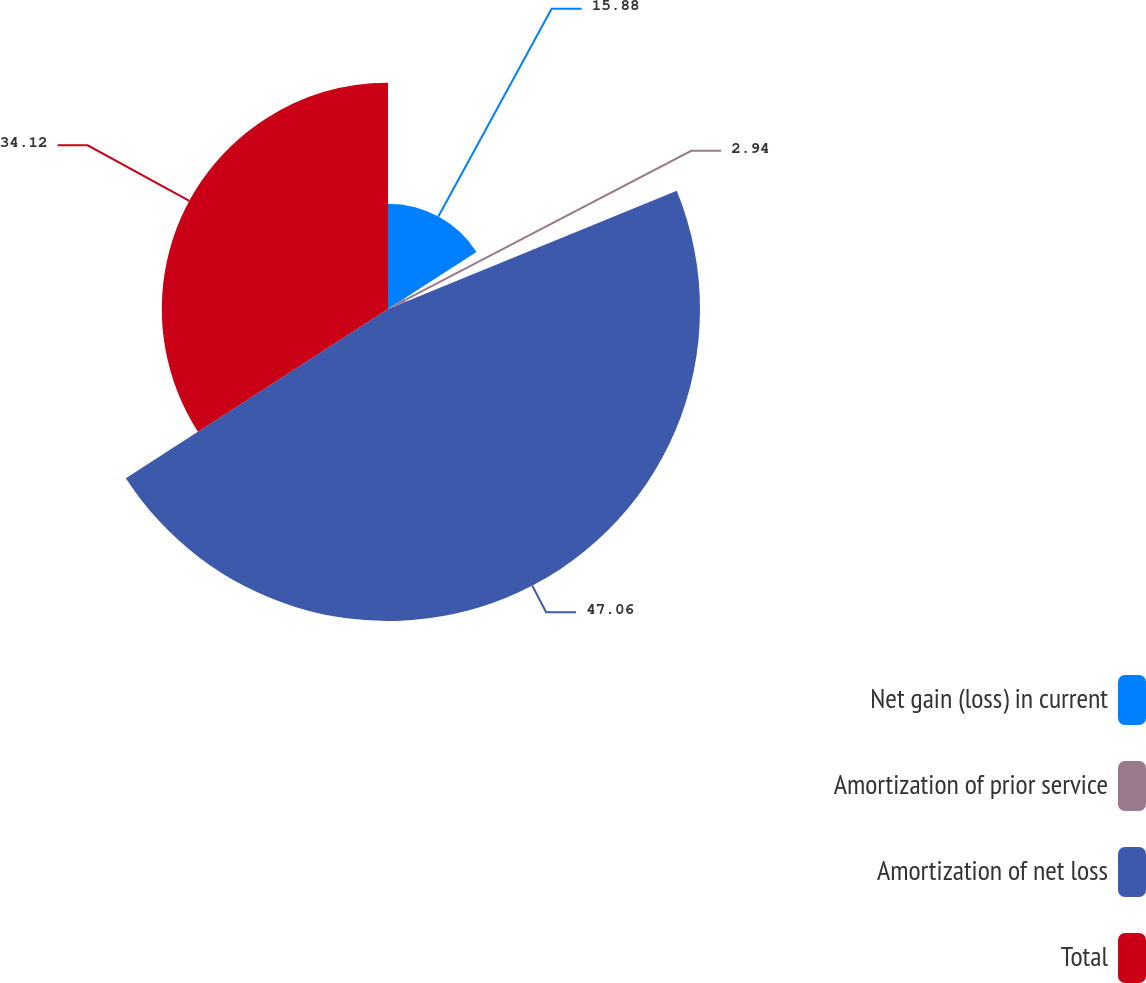<chart> <loc_0><loc_0><loc_500><loc_500><pie_chart><fcel>Net gain (loss) in current<fcel>Amortization of prior service<fcel>Amortization of net loss<fcel>Total<nl><fcel>15.88%<fcel>2.94%<fcel>47.06%<fcel>34.12%<nl></chart> 